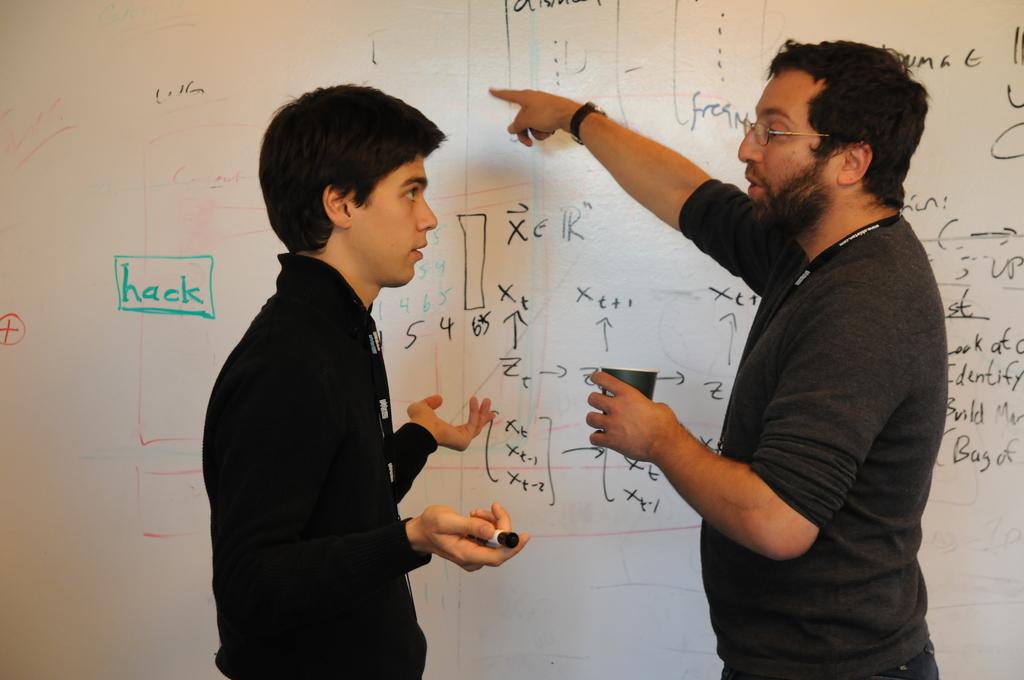What does the word inside the green box say?
Make the answer very short. Hack. 